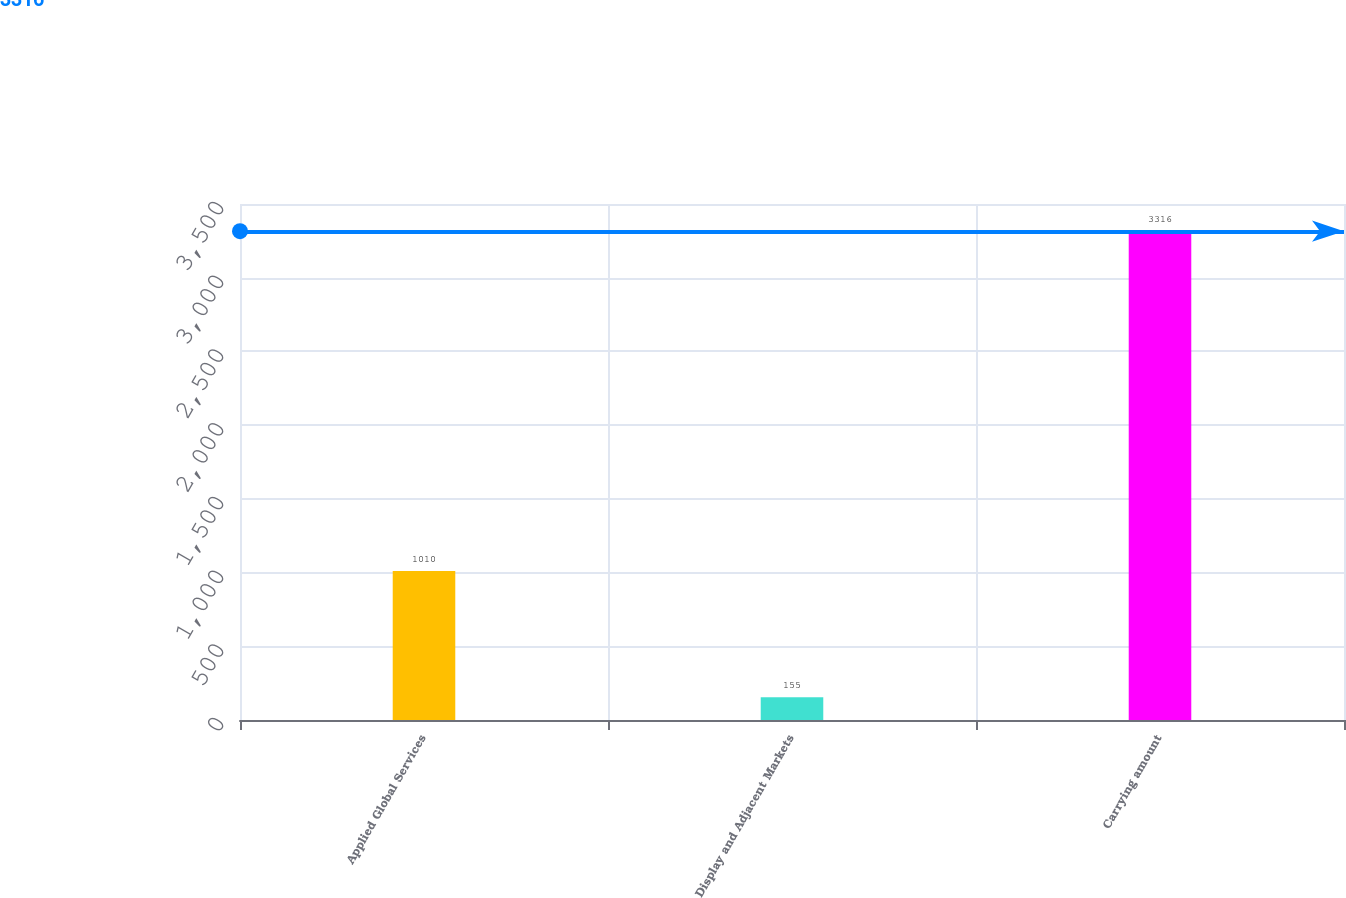Convert chart to OTSL. <chart><loc_0><loc_0><loc_500><loc_500><bar_chart><fcel>Applied Global Services<fcel>Display and Adjacent Markets<fcel>Carrying amount<nl><fcel>1010<fcel>155<fcel>3316<nl></chart> 